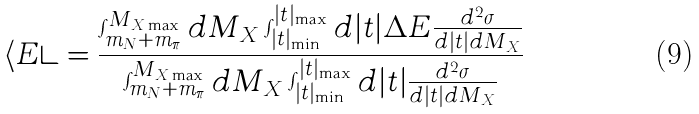<formula> <loc_0><loc_0><loc_500><loc_500>\langle E \rangle = \frac { \int _ { m _ { N } + m _ { \pi } } ^ { M _ { X \max } } d M _ { X } \int _ { | t | _ { \min } } ^ { | t | _ { \max } } d | t | \Delta E \frac { d ^ { 2 } \sigma } { d | t | d M _ { X } } } { \int _ { m _ { N } + m _ { \pi } } ^ { M _ { X \max } } d M _ { X } \int _ { | t | _ { \min } } ^ { | t | _ { \max } } d | t | \frac { d ^ { 2 } \sigma } { d | t | d M _ { X } } }</formula> 